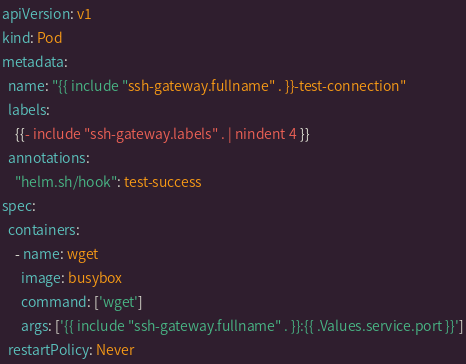<code> <loc_0><loc_0><loc_500><loc_500><_YAML_>apiVersion: v1
kind: Pod
metadata:
  name: "{{ include "ssh-gateway.fullname" . }}-test-connection"
  labels:
    {{- include "ssh-gateway.labels" . | nindent 4 }}
  annotations:
    "helm.sh/hook": test-success
spec:
  containers:
    - name: wget
      image: busybox
      command: ['wget']
      args: ['{{ include "ssh-gateway.fullname" . }}:{{ .Values.service.port }}']
  restartPolicy: Never
</code> 